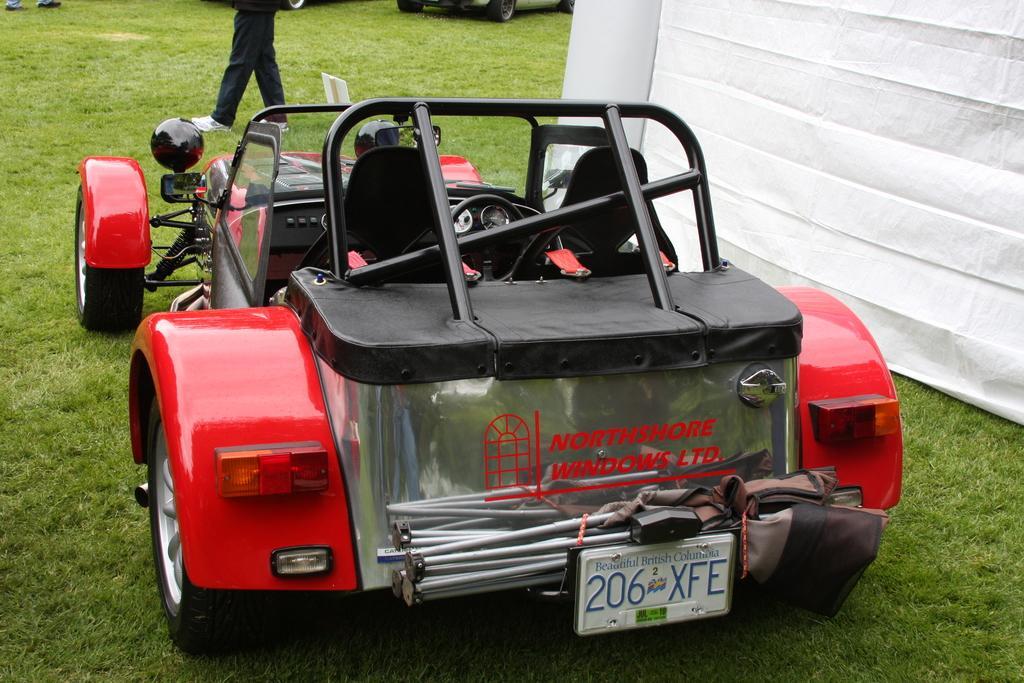Please provide a concise description of this image. This image consists of a car in red color. At the bottom, there is green grass on the ground. On the right, we can see a white cloth. It looks like a tent. In the background, we can see a man walking. And there are many cars on the ground. 